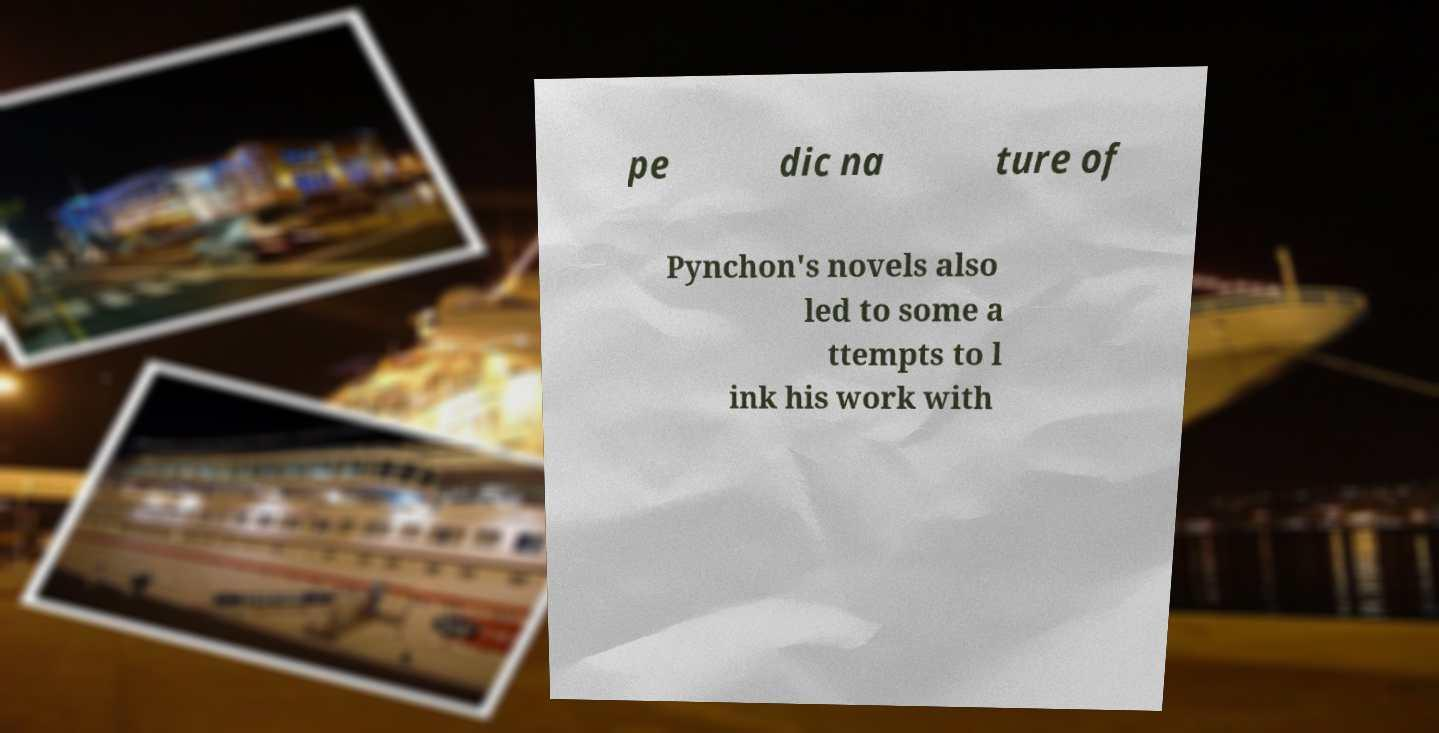Could you extract and type out the text from this image? pe dic na ture of Pynchon's novels also led to some a ttempts to l ink his work with 